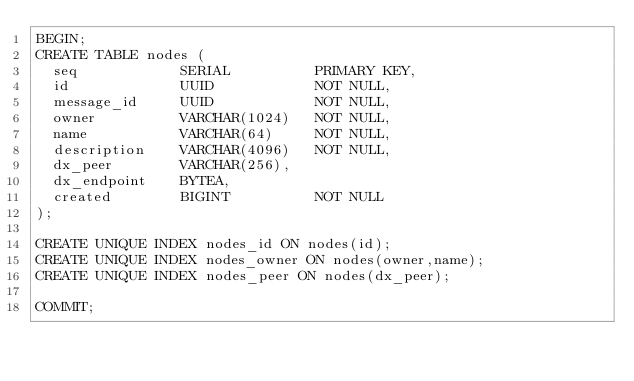<code> <loc_0><loc_0><loc_500><loc_500><_SQL_>BEGIN;
CREATE TABLE nodes (
  seq            SERIAL          PRIMARY KEY,
  id             UUID            NOT NULL,  
  message_id     UUID            NOT NULL,
  owner          VARCHAR(1024)   NOT NULL,
  name           VARCHAR(64)     NOT NULL,
  description    VARCHAR(4096)   NOT NULL,
  dx_peer        VARCHAR(256),
  dx_endpoint    BYTEA,
  created        BIGINT          NOT NULL
);

CREATE UNIQUE INDEX nodes_id ON nodes(id);
CREATE UNIQUE INDEX nodes_owner ON nodes(owner,name);
CREATE UNIQUE INDEX nodes_peer ON nodes(dx_peer);

COMMIT;</code> 